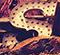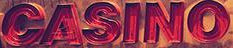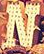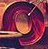Transcribe the words shown in these images in order, separated by a semicolon. S; CASINO; N; O 